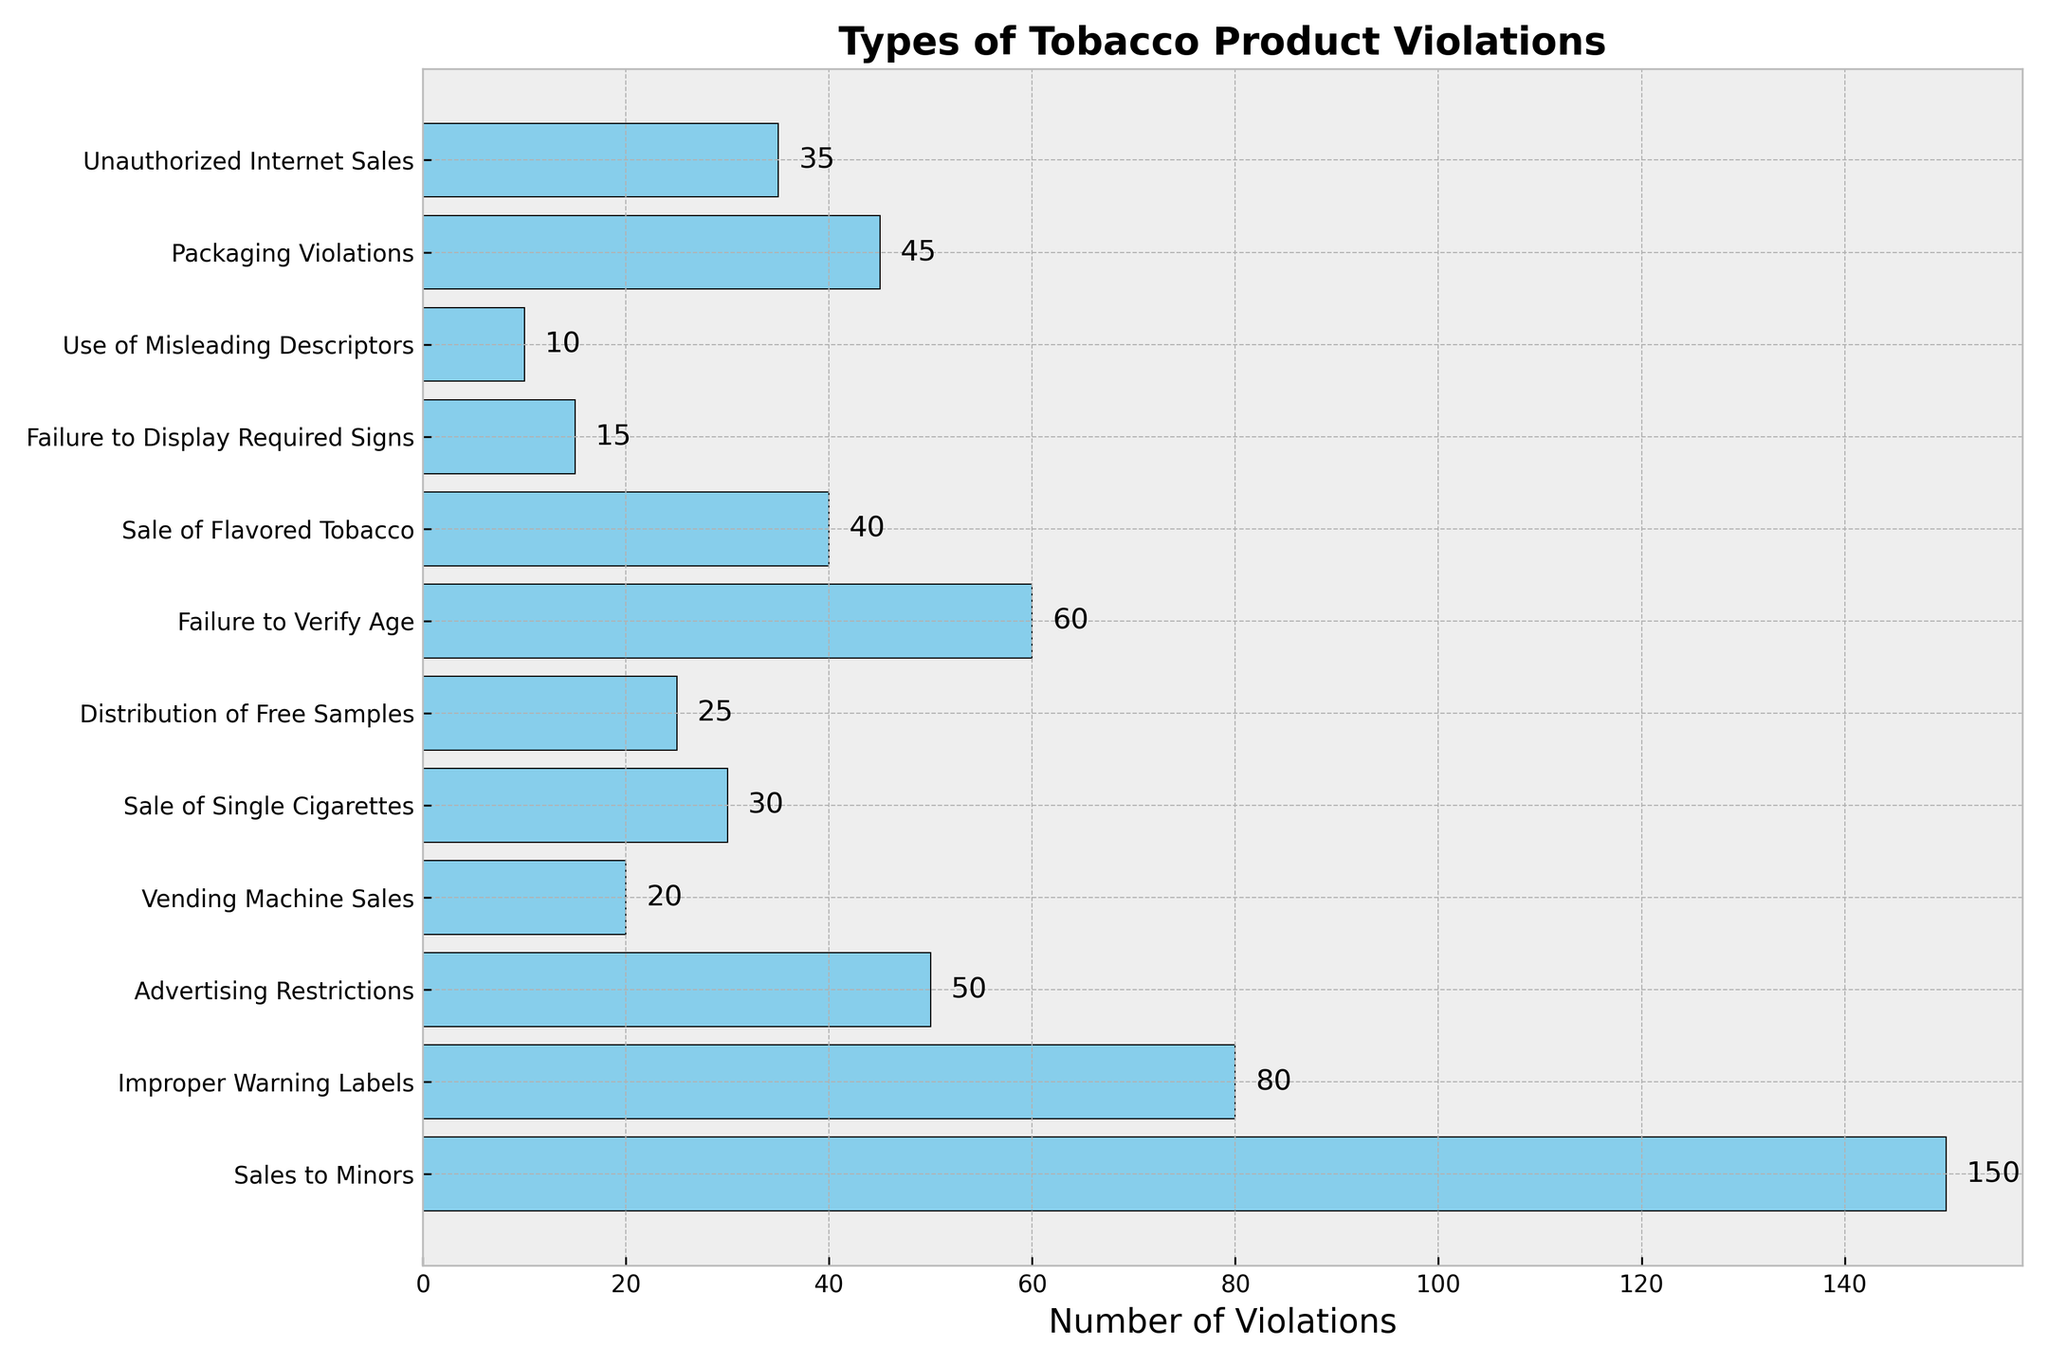What's the most frequent type of tobacco product violation? The sales to minors bar is the longest, indicating it has the highest number of violations among all types.
Answer: Sales to Minors Which type of violation has the least occurrences? The use of misleading descriptors bar is the shortest, indicating it has the fewest violations.
Answer: Use of Misleading Descriptors What is the total number of violations encountered by inspectors? Sum all the values for each type of violation: 150 + 80 + 50 + 20 + 30 + 25 + 60 + 40 + 15 + 10 + 45 + 35 = 560.
Answer: 560 How many more violations are there for sales to minors compared to improper warning labels? Sales to minors have 150 violations, while improper warning labels have 80. The difference is 150 - 80 = 70.
Answer: 70 What percentage of the total violations are due to failure to verify age? First, find the total number of violations (560). Failure to verify age has 60 violations. The percentage is (60/560) * 100 ≈ 10.71%.
Answer: ~10.71% How do the number of advertising restrictions violations compare to the sale of flavored tobacco violations? Advertising restrictions have 50 violations, while the sale of flavored tobacco has 40. Advertising restrictions have 10 more violations.
Answer: 10 more violations If you combine the violations for failure to verify age and unauthorized internet sales, what is the total? Failure to verify age has 60 violations, and unauthorized internet sales have 35. The combined total is 60 + 35 = 95.
Answer: 95 Which three types of violations have the highest occurrences? Sales to minors (150), improper warning labels (80), and failure to verify age (60) have the highest occurrences.
Answer: Sales to Minors, Improper Warning Labels, Failure to Verify Age What is the average number of violations per type? There are 12 types of violations in total. The total number of violations is 560. The average is 560 / 12 ≈ 46.67.
Answer: ~46.67 Which violation type has double the occurrences of the sale of single cigarettes? The sale of single cigarettes has 30 violations. Double that amount is 60, which corresponds to failure to verify age.
Answer: Failure to Verify Age 